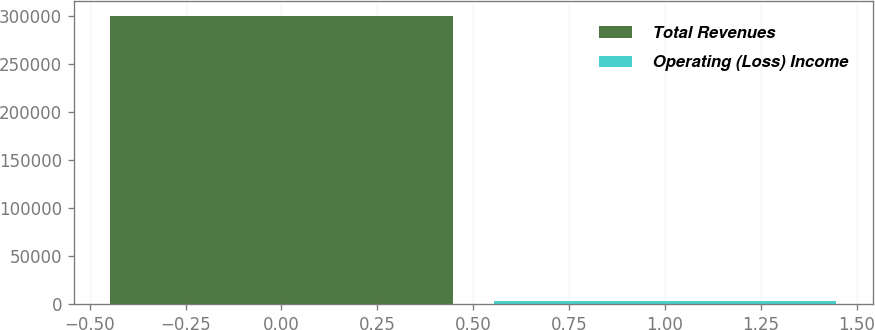Convert chart. <chart><loc_0><loc_0><loc_500><loc_500><bar_chart><fcel>Total Revenues<fcel>Operating (Loss) Income<nl><fcel>300538<fcel>3623<nl></chart> 